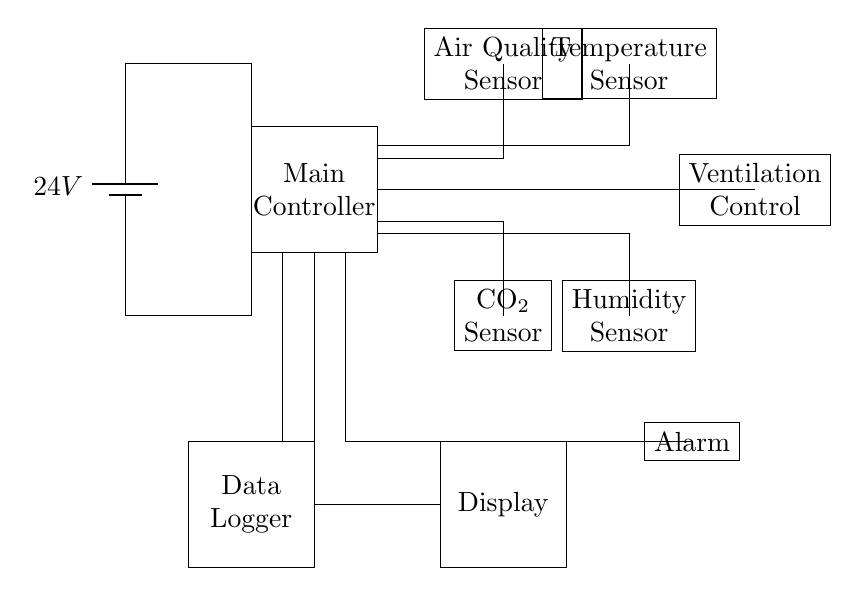What is the total number of sensors in this circuit? There are four sensors present in the circuit: an air quality sensor, a CO2 sensor, a temperature sensor, and a humidity sensor.
Answer: Four What is the voltage of the power supply? The power supply in this circuit is providing a voltage of 24 volts, as indicated by the battery symbol labeled with that voltage.
Answer: 24 volts What component controls the ventilation? The ventilation control component is represented by a rectangular block labeled "Ventilation Control," showing its role in managing airflow in response to sensor data.
Answer: Ventilation Control How many connections lead to the main controller? The main controller has two connections: one coming from the power supply and the other leading to the ventilation control component.
Answer: Two What is the purpose of the display in this circuit? The display is used to show real-time data from the sensors, allowing users to monitor air quality and environmental conditions in the classroom.
Answer: User Monitoring Explain how the alarm is triggered in the system. The alarm is connected to the main controller, which processes data from the various sensors; if certain thresholds (for example, too high CO2 levels or poor air quality) are surpassed, the controller sends a signal to activate the alarm, alerting users to the issue.
Answer: By the Main Controller 